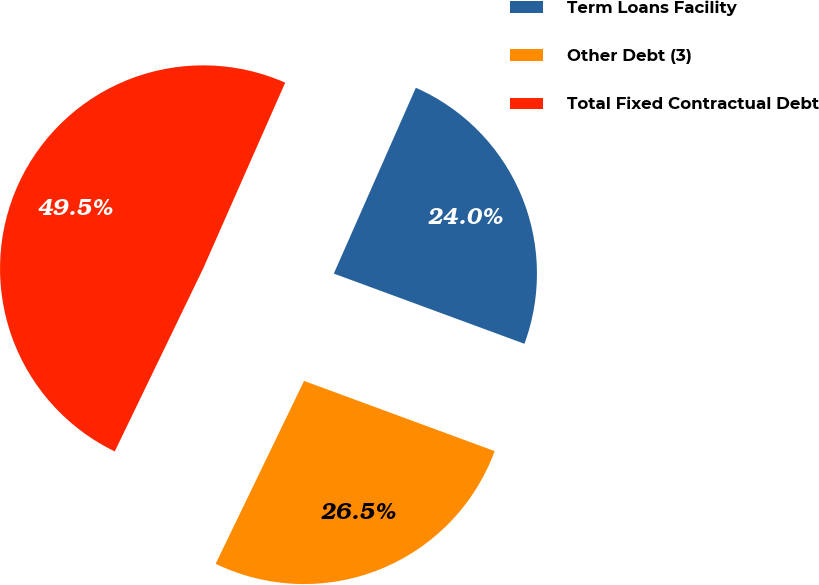Convert chart. <chart><loc_0><loc_0><loc_500><loc_500><pie_chart><fcel>Term Loans Facility<fcel>Other Debt (3)<fcel>Total Fixed Contractual Debt<nl><fcel>24.0%<fcel>26.55%<fcel>49.45%<nl></chart> 